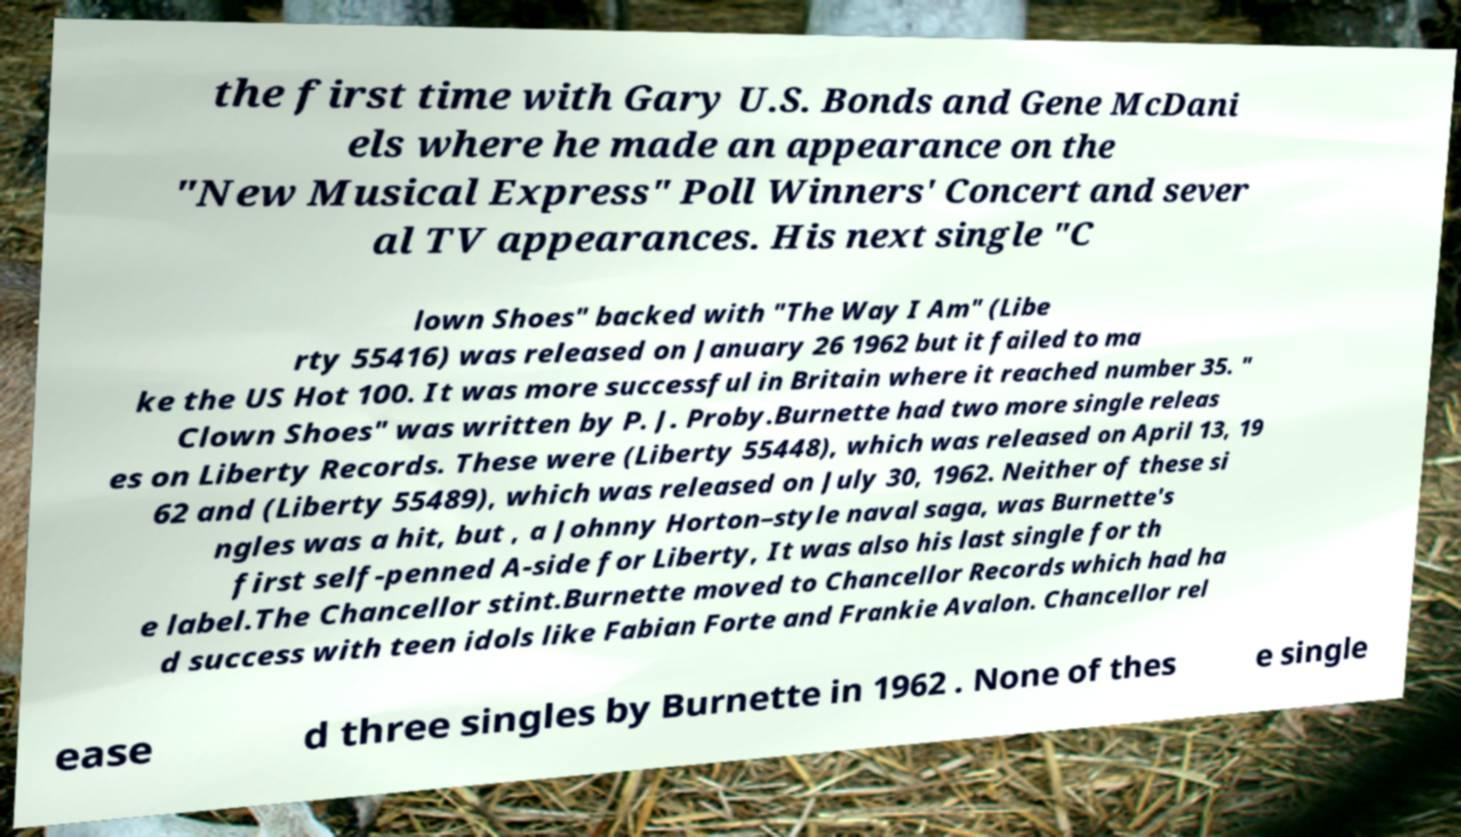Can you read and provide the text displayed in the image?This photo seems to have some interesting text. Can you extract and type it out for me? the first time with Gary U.S. Bonds and Gene McDani els where he made an appearance on the "New Musical Express" Poll Winners' Concert and sever al TV appearances. His next single "C lown Shoes" backed with "The Way I Am" (Libe rty 55416) was released on January 26 1962 but it failed to ma ke the US Hot 100. It was more successful in Britain where it reached number 35. " Clown Shoes" was written by P. J. Proby.Burnette had two more single releas es on Liberty Records. These were (Liberty 55448), which was released on April 13, 19 62 and (Liberty 55489), which was released on July 30, 1962. Neither of these si ngles was a hit, but , a Johnny Horton–style naval saga, was Burnette's first self-penned A-side for Liberty, It was also his last single for th e label.The Chancellor stint.Burnette moved to Chancellor Records which had ha d success with teen idols like Fabian Forte and Frankie Avalon. Chancellor rel ease d three singles by Burnette in 1962 . None of thes e single 